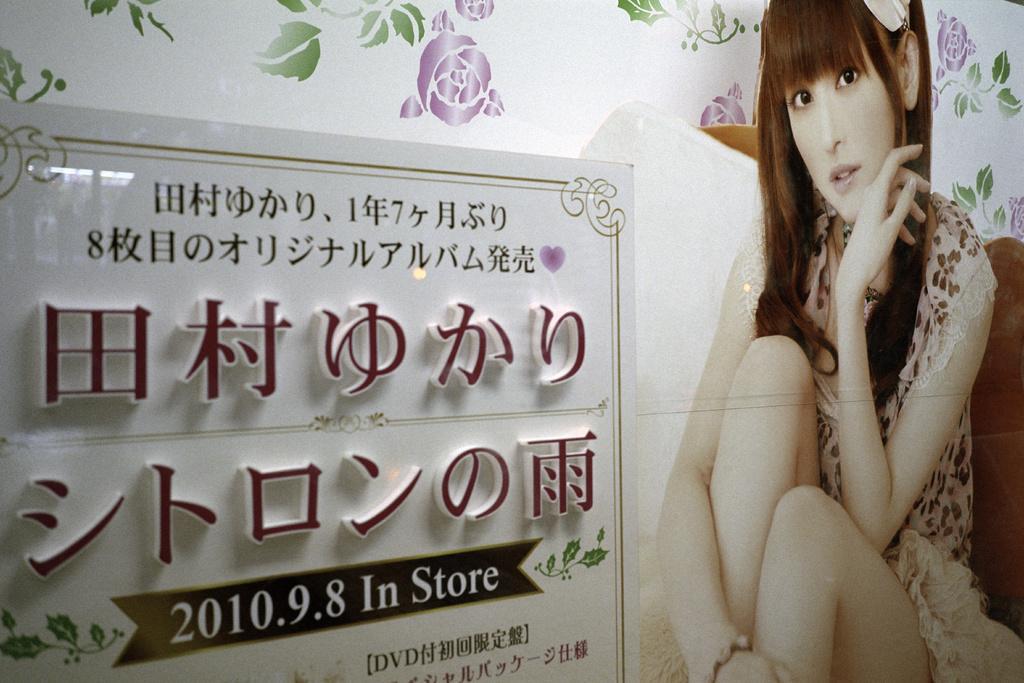Describe this image in one or two sentences. This image consists of a poster. On the right, there is a girl sitting. On the left, there is a board on which there is a text. At the top, there is a print of flowers along with leaves. 